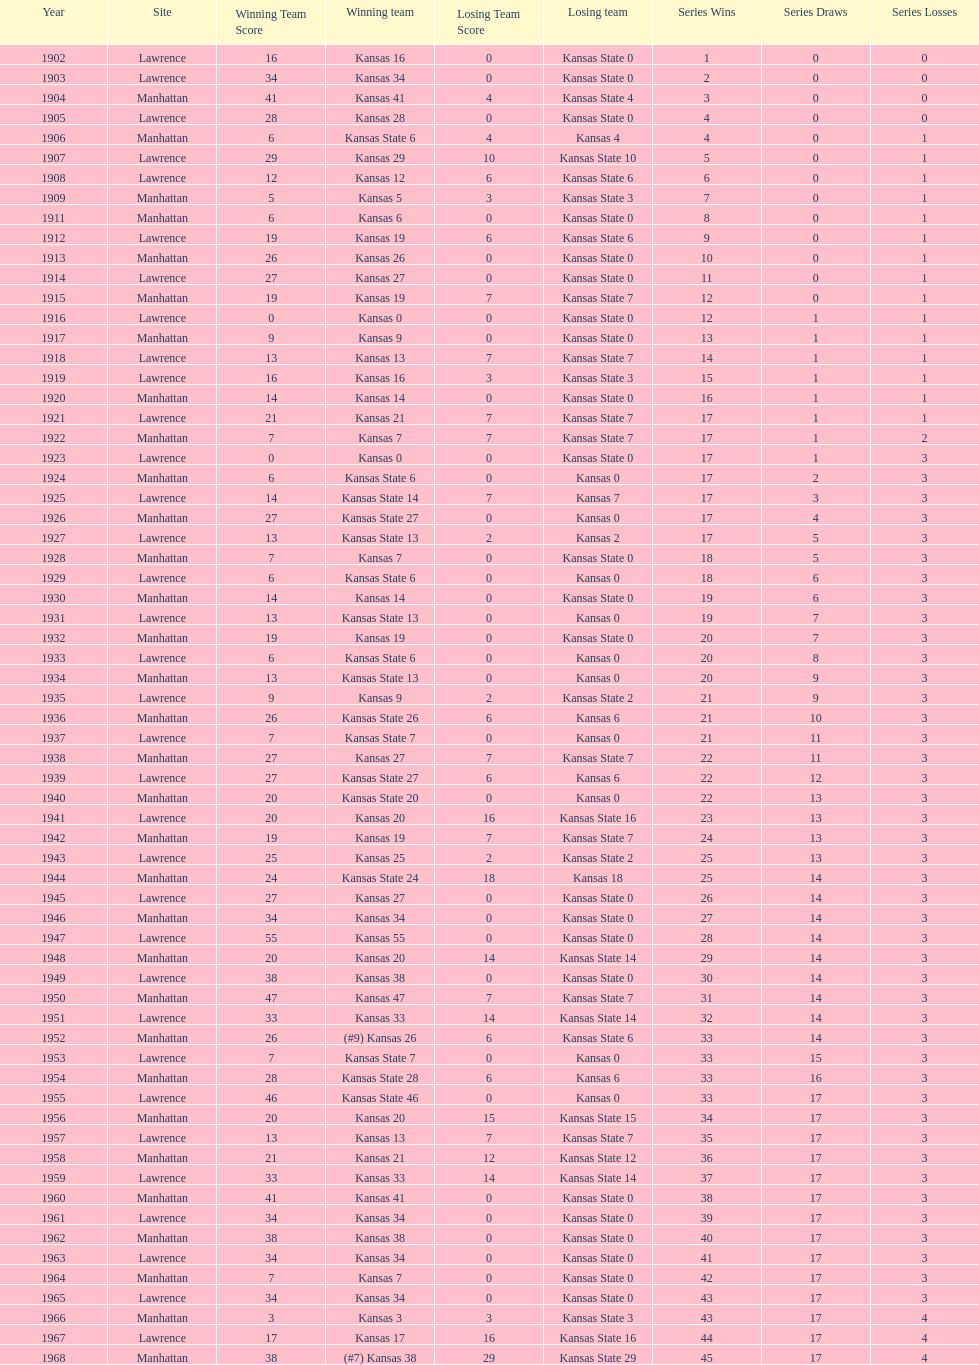How many times did kansas state not score at all against kansas from 1902-1968? 23. 